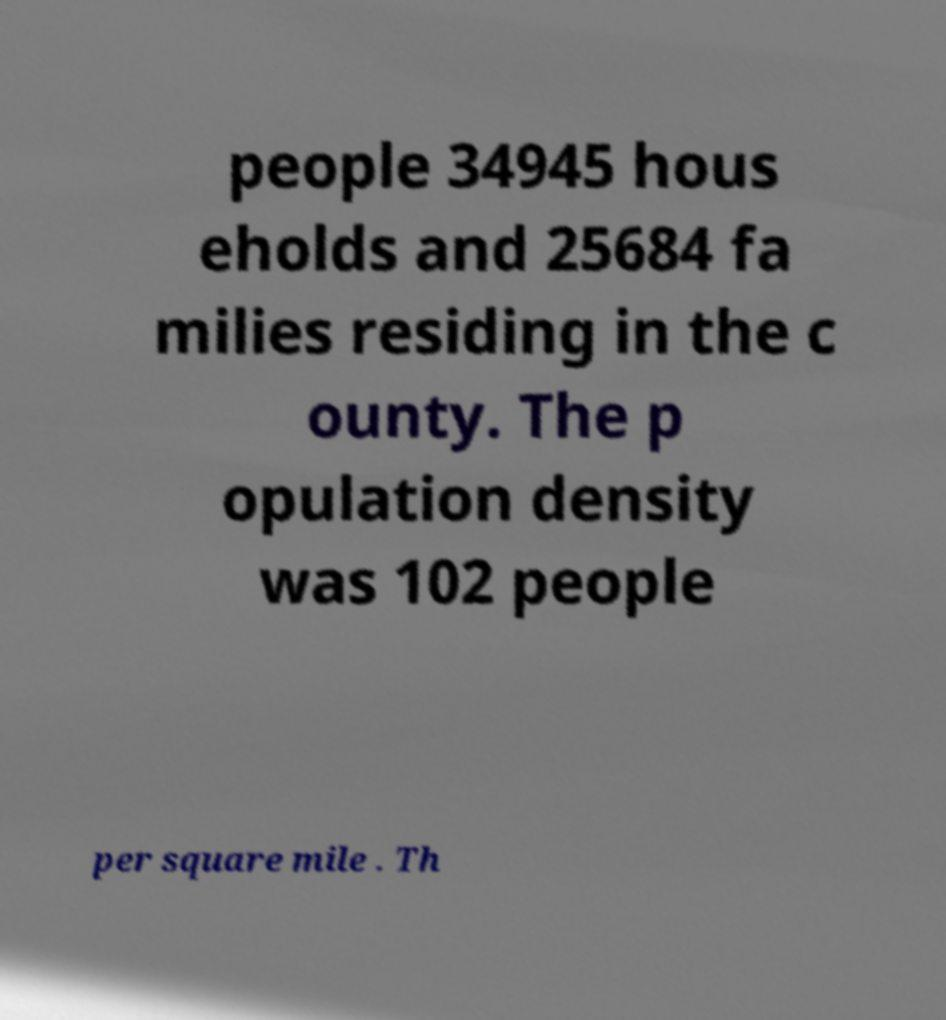Please identify and transcribe the text found in this image. people 34945 hous eholds and 25684 fa milies residing in the c ounty. The p opulation density was 102 people per square mile . Th 